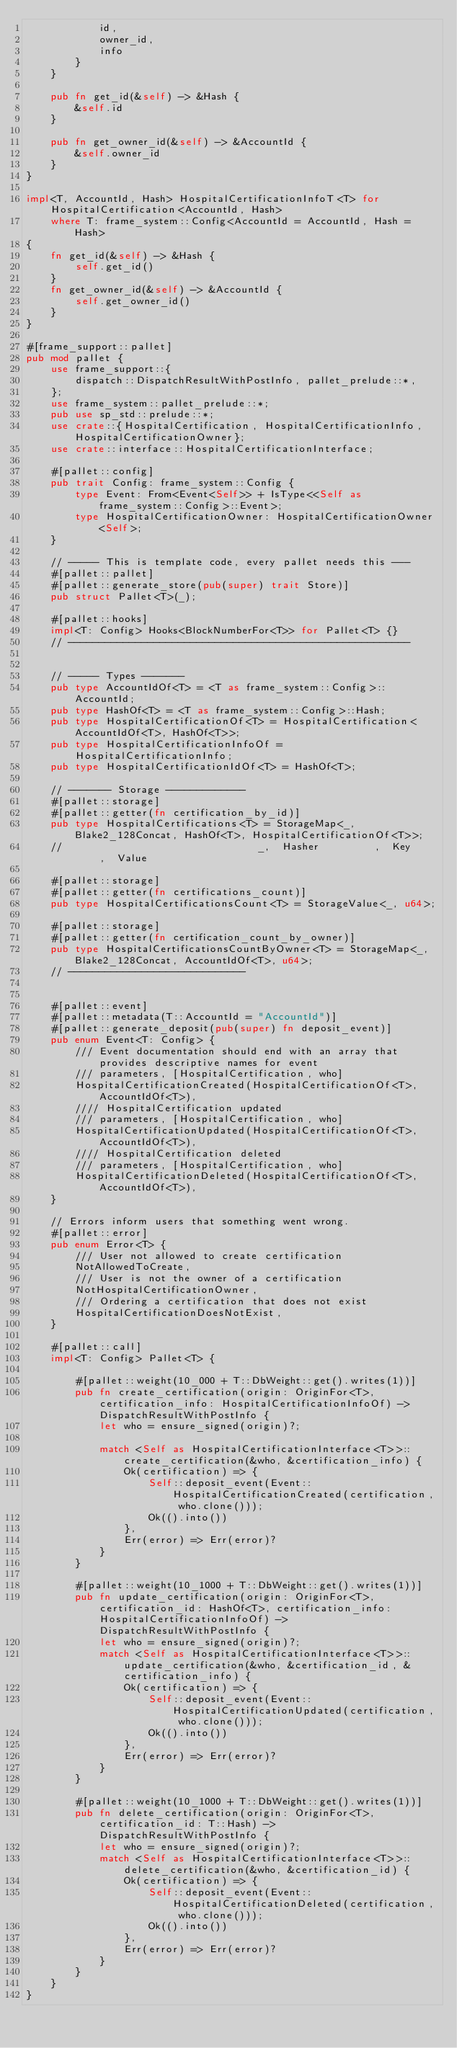Convert code to text. <code><loc_0><loc_0><loc_500><loc_500><_Rust_>            id,
            owner_id,
            info
        }
    }

    pub fn get_id(&self) -> &Hash {
        &self.id
    }

    pub fn get_owner_id(&self) -> &AccountId {
        &self.owner_id
    }
}

impl<T, AccountId, Hash> HospitalCertificationInfoT<T> for HospitalCertification<AccountId, Hash>
    where T: frame_system::Config<AccountId = AccountId, Hash = Hash>
{
    fn get_id(&self) -> &Hash {
        self.get_id()
    }
    fn get_owner_id(&self) -> &AccountId {
        self.get_owner_id()
    }
}

#[frame_support::pallet]
pub mod pallet {
    use frame_support::{
        dispatch::DispatchResultWithPostInfo, pallet_prelude::*,
    };
    use frame_system::pallet_prelude::*;
    pub use sp_std::prelude::*;
    use crate::{HospitalCertification, HospitalCertificationInfo, HospitalCertificationOwner};
    use crate::interface::HospitalCertificationInterface;

    #[pallet::config]
    pub trait Config: frame_system::Config {
        type Event: From<Event<Self>> + IsType<<Self as frame_system::Config>::Event>;
        type HospitalCertificationOwner: HospitalCertificationOwner<Self>;
    }

    // ----- This is template code, every pallet needs this ---
    #[pallet::pallet]
    #[pallet::generate_store(pub(super) trait Store)]
    pub struct Pallet<T>(_);

    #[pallet::hooks]
    impl<T: Config> Hooks<BlockNumberFor<T>> for Pallet<T> {}
    // --------------------------------------------------------
    

    // ----- Types -------
    pub type AccountIdOf<T> = <T as frame_system::Config>::AccountId;
    pub type HashOf<T> = <T as frame_system::Config>::Hash;
    pub type HospitalCertificationOf<T> = HospitalCertification<AccountIdOf<T>, HashOf<T>>;
    pub type HospitalCertificationInfoOf = HospitalCertificationInfo;
    pub type HospitalCertificationIdOf<T> = HashOf<T>;

    // ------- Storage -------------
    #[pallet::storage]
    #[pallet::getter(fn certification_by_id)]
    pub type HospitalCertifications<T> = StorageMap<_, Blake2_128Concat, HashOf<T>, HospitalCertificationOf<T>>;
    //                                _,  Hasher         ,  Key     ,  Value

    #[pallet::storage]
    #[pallet::getter(fn certifications_count)]
    pub type HospitalCertificationsCount<T> = StorageValue<_, u64>;

    #[pallet::storage]
    #[pallet::getter(fn certification_count_by_owner)]
    pub type HospitalCertificationsCountByOwner<T> = StorageMap<_, Blake2_128Concat, AccountIdOf<T>, u64>;
    // -----------------------------


    #[pallet::event]
    #[pallet::metadata(T::AccountId = "AccountId")]
    #[pallet::generate_deposit(pub(super) fn deposit_event)]
    pub enum Event<T: Config> {
        /// Event documentation should end with an array that provides descriptive names for event
        /// parameters, [HospitalCertification, who]
        HospitalCertificationCreated(HospitalCertificationOf<T>, AccountIdOf<T>),
        //// HospitalCertification updated
        /// parameters, [HospitalCertification, who]
        HospitalCertificationUpdated(HospitalCertificationOf<T>, AccountIdOf<T>),
        //// HospitalCertification deleted
        /// parameters, [HospitalCertification, who]
        HospitalCertificationDeleted(HospitalCertificationOf<T>, AccountIdOf<T>),
    }

    // Errors inform users that something went wrong.
    #[pallet::error]
    pub enum Error<T> {
        /// User not allowed to create certification
        NotAllowedToCreate,
        /// User is not the owner of a certification
        NotHospitalCertificationOwner,
        /// Ordering a certification that does not exist
        HospitalCertificationDoesNotExist,
    }
    
    #[pallet::call]
    impl<T: Config> Pallet<T> {
        
        #[pallet::weight(10_000 + T::DbWeight::get().writes(1))]
        pub fn create_certification(origin: OriginFor<T>, certification_info: HospitalCertificationInfoOf) -> DispatchResultWithPostInfo {
            let who = ensure_signed(origin)?;

            match <Self as HospitalCertificationInterface<T>>::create_certification(&who, &certification_info) {
                Ok(certification) => {
                    Self::deposit_event(Event::HospitalCertificationCreated(certification, who.clone()));
                    Ok(().into())
                },
                Err(error) => Err(error)?
            }
        }
        
        #[pallet::weight(10_1000 + T::DbWeight::get().writes(1))]
        pub fn update_certification(origin: OriginFor<T>, certification_id: HashOf<T>, certification_info: HospitalCertificationInfoOf) -> DispatchResultWithPostInfo {
            let who = ensure_signed(origin)?;
            match <Self as HospitalCertificationInterface<T>>::update_certification(&who, &certification_id, &certification_info) {
                Ok(certification) => {
                    Self::deposit_event(Event::HospitalCertificationUpdated(certification, who.clone()));
                    Ok(().into())
                },
                Err(error) => Err(error)?
            }
        }

        #[pallet::weight(10_1000 + T::DbWeight::get().writes(1))]
        pub fn delete_certification(origin: OriginFor<T>, certification_id: T::Hash) -> DispatchResultWithPostInfo {
            let who = ensure_signed(origin)?;
            match <Self as HospitalCertificationInterface<T>>::delete_certification(&who, &certification_id) {
                Ok(certification) => {
                    Self::deposit_event(Event::HospitalCertificationDeleted(certification, who.clone()));
                    Ok(().into())
                },
                Err(error) => Err(error)?
            }
        }
    }
}
</code> 